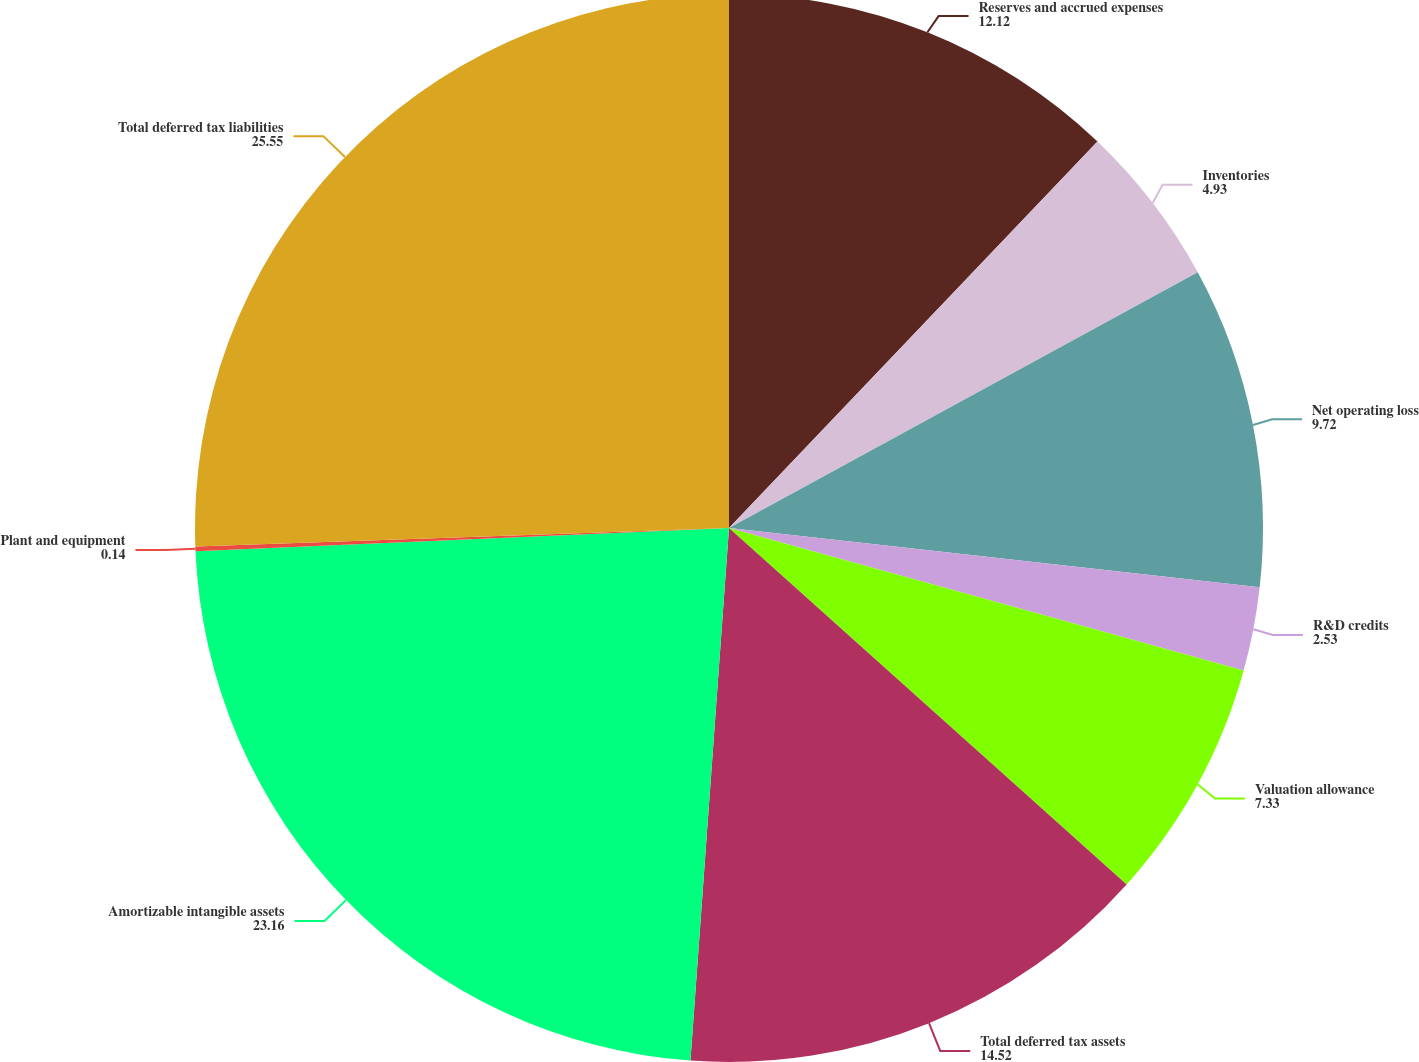<chart> <loc_0><loc_0><loc_500><loc_500><pie_chart><fcel>Reserves and accrued expenses<fcel>Inventories<fcel>Net operating loss<fcel>R&D credits<fcel>Valuation allowance<fcel>Total deferred tax assets<fcel>Amortizable intangible assets<fcel>Plant and equipment<fcel>Total deferred tax liabilities<nl><fcel>12.12%<fcel>4.93%<fcel>9.72%<fcel>2.53%<fcel>7.33%<fcel>14.52%<fcel>23.16%<fcel>0.14%<fcel>25.55%<nl></chart> 